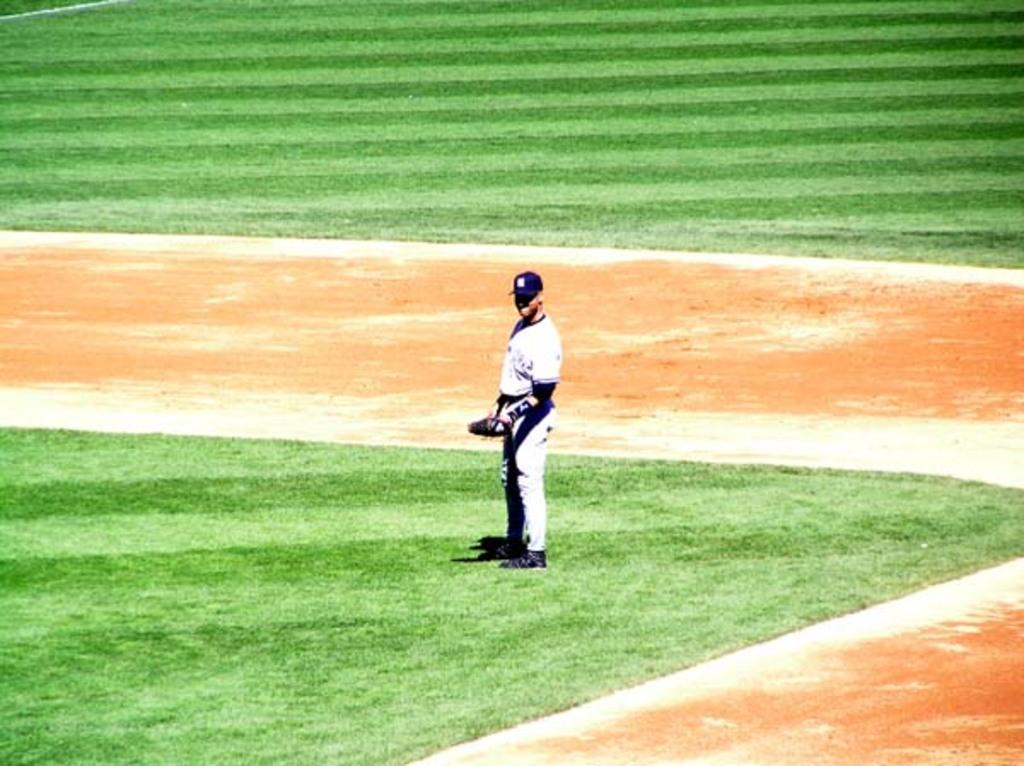Where was the image taken? The image was clicked outside. What is the main subject of the image? There is a person in the center of the image. What is the person holding in the image? The person is holding an object. What is the person's position in relation to the ground? The person is standing on the ground. What type of vegetation can be seen on the ground? Green grass is visible on the ground. How many sisters does the doll have in the image? There is no doll present in the image, so it is not possible to determine how many sisters the doll might have. What type of playground equipment can be seen in the image? There is no playground equipment visible in the image. 